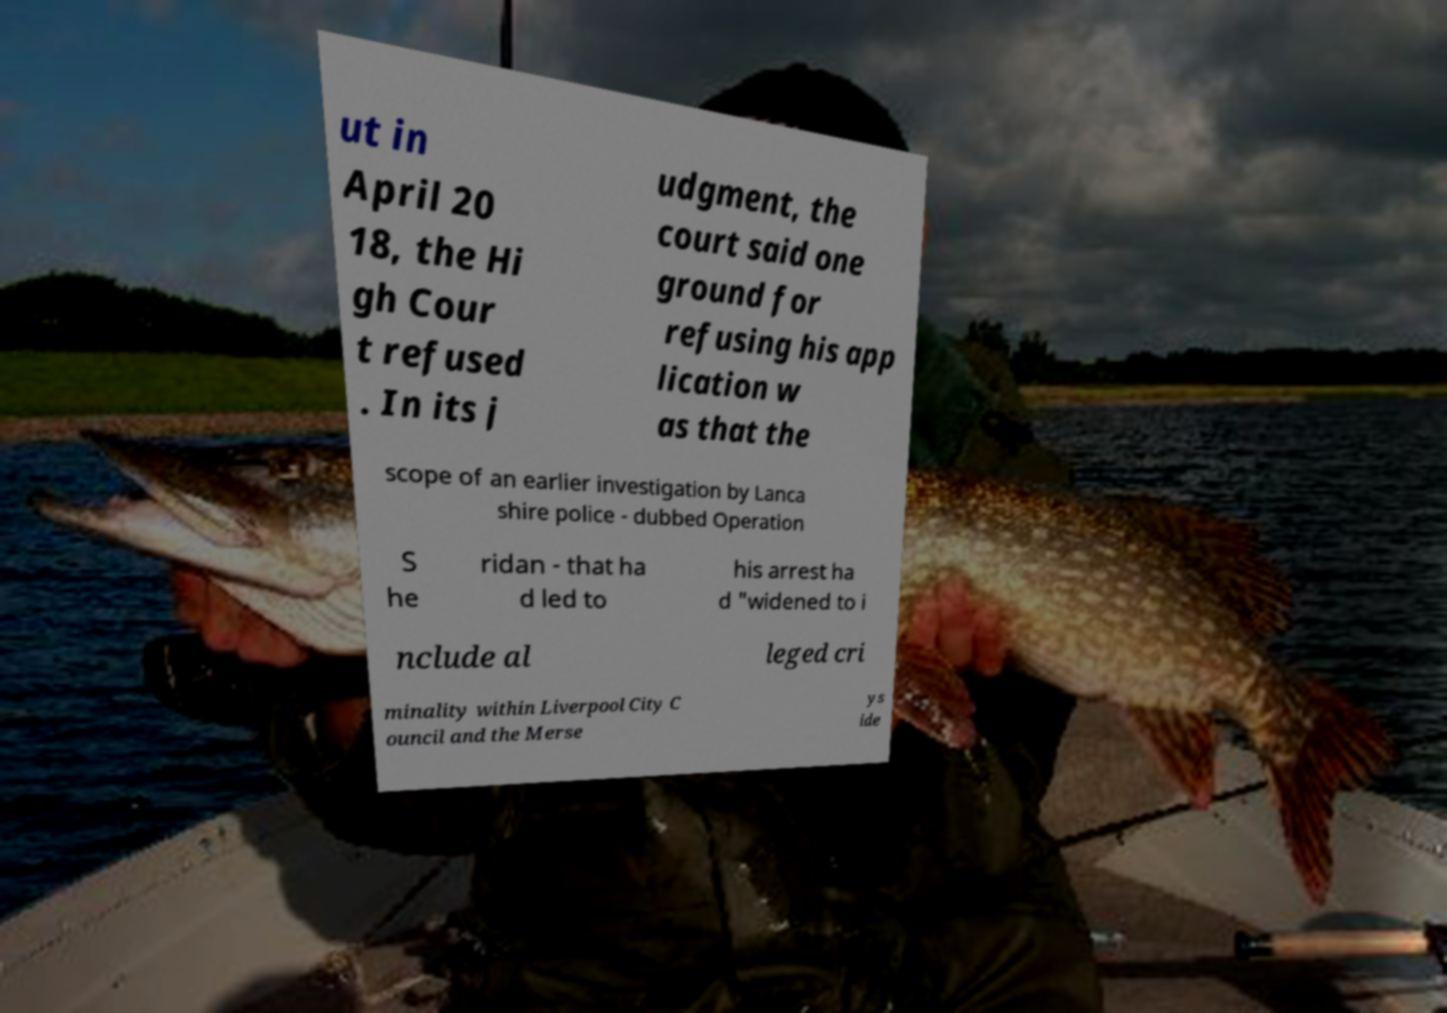For documentation purposes, I need the text within this image transcribed. Could you provide that? ut in April 20 18, the Hi gh Cour t refused . In its j udgment, the court said one ground for refusing his app lication w as that the scope of an earlier investigation by Lanca shire police - dubbed Operation S he ridan - that ha d led to his arrest ha d "widened to i nclude al leged cri minality within Liverpool City C ouncil and the Merse ys ide 